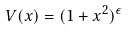Convert formula to latex. <formula><loc_0><loc_0><loc_500><loc_500>V ( x ) = ( 1 + x ^ { 2 } ) ^ { \epsilon }</formula> 